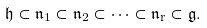Convert formula to latex. <formula><loc_0><loc_0><loc_500><loc_500>\mathfrak { h } \subset \mathfrak { n } _ { 1 } \subset \mathfrak { n } _ { 2 } \subset \dots \subset \mathfrak { n } _ { r } \subset \mathfrak { g } .</formula> 